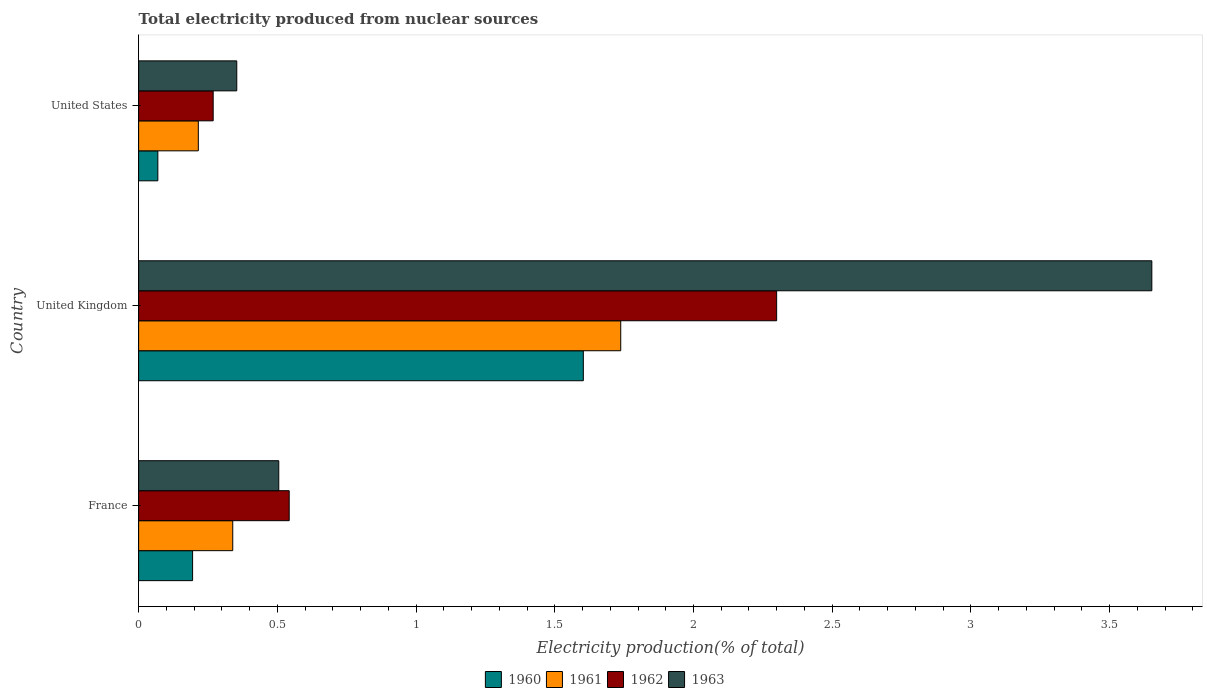How many different coloured bars are there?
Offer a very short reply. 4. Are the number of bars per tick equal to the number of legend labels?
Keep it short and to the point. Yes. How many bars are there on the 1st tick from the top?
Your answer should be compact. 4. In how many cases, is the number of bars for a given country not equal to the number of legend labels?
Offer a very short reply. 0. What is the total electricity produced in 1961 in United Kingdom?
Offer a terse response. 1.74. Across all countries, what is the maximum total electricity produced in 1960?
Offer a very short reply. 1.6. Across all countries, what is the minimum total electricity produced in 1961?
Provide a succinct answer. 0.22. In which country was the total electricity produced in 1961 minimum?
Offer a very short reply. United States. What is the total total electricity produced in 1960 in the graph?
Offer a very short reply. 1.87. What is the difference between the total electricity produced in 1963 in France and that in United Kingdom?
Provide a succinct answer. -3.15. What is the difference between the total electricity produced in 1961 in France and the total electricity produced in 1960 in United Kingdom?
Your answer should be compact. -1.26. What is the average total electricity produced in 1963 per country?
Your answer should be very brief. 1.5. What is the difference between the total electricity produced in 1961 and total electricity produced in 1963 in United States?
Your answer should be very brief. -0.14. In how many countries, is the total electricity produced in 1962 greater than 1.3 %?
Offer a very short reply. 1. What is the ratio of the total electricity produced in 1961 in France to that in United States?
Offer a very short reply. 1.58. Is the total electricity produced in 1960 in United Kingdom less than that in United States?
Your answer should be very brief. No. Is the difference between the total electricity produced in 1961 in United Kingdom and United States greater than the difference between the total electricity produced in 1963 in United Kingdom and United States?
Keep it short and to the point. No. What is the difference between the highest and the second highest total electricity produced in 1961?
Provide a succinct answer. 1.4. What is the difference between the highest and the lowest total electricity produced in 1961?
Provide a succinct answer. 1.52. In how many countries, is the total electricity produced in 1961 greater than the average total electricity produced in 1961 taken over all countries?
Offer a terse response. 1. Is it the case that in every country, the sum of the total electricity produced in 1963 and total electricity produced in 1960 is greater than the sum of total electricity produced in 1962 and total electricity produced in 1961?
Give a very brief answer. No. What does the 2nd bar from the top in United States represents?
Provide a succinct answer. 1962. What does the 4th bar from the bottom in United Kingdom represents?
Offer a very short reply. 1963. How many bars are there?
Ensure brevity in your answer.  12. What is the difference between two consecutive major ticks on the X-axis?
Keep it short and to the point. 0.5. Does the graph contain grids?
Your answer should be very brief. No. Where does the legend appear in the graph?
Your answer should be very brief. Bottom center. How are the legend labels stacked?
Ensure brevity in your answer.  Horizontal. What is the title of the graph?
Provide a short and direct response. Total electricity produced from nuclear sources. Does "2012" appear as one of the legend labels in the graph?
Ensure brevity in your answer.  No. What is the Electricity production(% of total) in 1960 in France?
Provide a succinct answer. 0.19. What is the Electricity production(% of total) of 1961 in France?
Your answer should be very brief. 0.34. What is the Electricity production(% of total) of 1962 in France?
Ensure brevity in your answer.  0.54. What is the Electricity production(% of total) of 1963 in France?
Your response must be concise. 0.51. What is the Electricity production(% of total) in 1960 in United Kingdom?
Provide a succinct answer. 1.6. What is the Electricity production(% of total) of 1961 in United Kingdom?
Offer a very short reply. 1.74. What is the Electricity production(% of total) in 1962 in United Kingdom?
Offer a very short reply. 2.3. What is the Electricity production(% of total) of 1963 in United Kingdom?
Offer a terse response. 3.65. What is the Electricity production(% of total) of 1960 in United States?
Your answer should be compact. 0.07. What is the Electricity production(% of total) in 1961 in United States?
Offer a terse response. 0.22. What is the Electricity production(% of total) in 1962 in United States?
Keep it short and to the point. 0.27. What is the Electricity production(% of total) in 1963 in United States?
Make the answer very short. 0.35. Across all countries, what is the maximum Electricity production(% of total) of 1960?
Your response must be concise. 1.6. Across all countries, what is the maximum Electricity production(% of total) in 1961?
Your answer should be very brief. 1.74. Across all countries, what is the maximum Electricity production(% of total) of 1962?
Keep it short and to the point. 2.3. Across all countries, what is the maximum Electricity production(% of total) in 1963?
Offer a very short reply. 3.65. Across all countries, what is the minimum Electricity production(% of total) in 1960?
Offer a very short reply. 0.07. Across all countries, what is the minimum Electricity production(% of total) in 1961?
Keep it short and to the point. 0.22. Across all countries, what is the minimum Electricity production(% of total) of 1962?
Give a very brief answer. 0.27. Across all countries, what is the minimum Electricity production(% of total) in 1963?
Give a very brief answer. 0.35. What is the total Electricity production(% of total) in 1960 in the graph?
Your answer should be very brief. 1.87. What is the total Electricity production(% of total) in 1961 in the graph?
Make the answer very short. 2.29. What is the total Electricity production(% of total) of 1962 in the graph?
Provide a succinct answer. 3.11. What is the total Electricity production(% of total) in 1963 in the graph?
Provide a short and direct response. 4.51. What is the difference between the Electricity production(% of total) of 1960 in France and that in United Kingdom?
Your answer should be very brief. -1.41. What is the difference between the Electricity production(% of total) of 1961 in France and that in United Kingdom?
Offer a terse response. -1.4. What is the difference between the Electricity production(% of total) of 1962 in France and that in United Kingdom?
Your answer should be compact. -1.76. What is the difference between the Electricity production(% of total) in 1963 in France and that in United Kingdom?
Your answer should be very brief. -3.15. What is the difference between the Electricity production(% of total) of 1960 in France and that in United States?
Ensure brevity in your answer.  0.13. What is the difference between the Electricity production(% of total) in 1961 in France and that in United States?
Provide a short and direct response. 0.12. What is the difference between the Electricity production(% of total) in 1962 in France and that in United States?
Your response must be concise. 0.27. What is the difference between the Electricity production(% of total) in 1963 in France and that in United States?
Make the answer very short. 0.15. What is the difference between the Electricity production(% of total) of 1960 in United Kingdom and that in United States?
Offer a very short reply. 1.53. What is the difference between the Electricity production(% of total) of 1961 in United Kingdom and that in United States?
Offer a terse response. 1.52. What is the difference between the Electricity production(% of total) in 1962 in United Kingdom and that in United States?
Your answer should be compact. 2.03. What is the difference between the Electricity production(% of total) in 1963 in United Kingdom and that in United States?
Offer a terse response. 3.3. What is the difference between the Electricity production(% of total) of 1960 in France and the Electricity production(% of total) of 1961 in United Kingdom?
Make the answer very short. -1.54. What is the difference between the Electricity production(% of total) of 1960 in France and the Electricity production(% of total) of 1962 in United Kingdom?
Offer a very short reply. -2.11. What is the difference between the Electricity production(% of total) in 1960 in France and the Electricity production(% of total) in 1963 in United Kingdom?
Keep it short and to the point. -3.46. What is the difference between the Electricity production(% of total) in 1961 in France and the Electricity production(% of total) in 1962 in United Kingdom?
Your answer should be compact. -1.96. What is the difference between the Electricity production(% of total) of 1961 in France and the Electricity production(% of total) of 1963 in United Kingdom?
Provide a short and direct response. -3.31. What is the difference between the Electricity production(% of total) in 1962 in France and the Electricity production(% of total) in 1963 in United Kingdom?
Keep it short and to the point. -3.11. What is the difference between the Electricity production(% of total) in 1960 in France and the Electricity production(% of total) in 1961 in United States?
Make the answer very short. -0.02. What is the difference between the Electricity production(% of total) in 1960 in France and the Electricity production(% of total) in 1962 in United States?
Give a very brief answer. -0.07. What is the difference between the Electricity production(% of total) of 1960 in France and the Electricity production(% of total) of 1963 in United States?
Keep it short and to the point. -0.16. What is the difference between the Electricity production(% of total) in 1961 in France and the Electricity production(% of total) in 1962 in United States?
Provide a succinct answer. 0.07. What is the difference between the Electricity production(% of total) in 1961 in France and the Electricity production(% of total) in 1963 in United States?
Give a very brief answer. -0.01. What is the difference between the Electricity production(% of total) in 1962 in France and the Electricity production(% of total) in 1963 in United States?
Offer a terse response. 0.19. What is the difference between the Electricity production(% of total) of 1960 in United Kingdom and the Electricity production(% of total) of 1961 in United States?
Make the answer very short. 1.39. What is the difference between the Electricity production(% of total) of 1960 in United Kingdom and the Electricity production(% of total) of 1962 in United States?
Provide a succinct answer. 1.33. What is the difference between the Electricity production(% of total) in 1960 in United Kingdom and the Electricity production(% of total) in 1963 in United States?
Give a very brief answer. 1.25. What is the difference between the Electricity production(% of total) in 1961 in United Kingdom and the Electricity production(% of total) in 1962 in United States?
Provide a short and direct response. 1.47. What is the difference between the Electricity production(% of total) in 1961 in United Kingdom and the Electricity production(% of total) in 1963 in United States?
Your response must be concise. 1.38. What is the difference between the Electricity production(% of total) of 1962 in United Kingdom and the Electricity production(% of total) of 1963 in United States?
Your answer should be very brief. 1.95. What is the average Electricity production(% of total) of 1960 per country?
Your answer should be very brief. 0.62. What is the average Electricity production(% of total) in 1961 per country?
Give a very brief answer. 0.76. What is the average Electricity production(% of total) in 1963 per country?
Offer a terse response. 1.5. What is the difference between the Electricity production(% of total) in 1960 and Electricity production(% of total) in 1961 in France?
Provide a succinct answer. -0.14. What is the difference between the Electricity production(% of total) of 1960 and Electricity production(% of total) of 1962 in France?
Provide a succinct answer. -0.35. What is the difference between the Electricity production(% of total) in 1960 and Electricity production(% of total) in 1963 in France?
Your response must be concise. -0.31. What is the difference between the Electricity production(% of total) of 1961 and Electricity production(% of total) of 1962 in France?
Provide a succinct answer. -0.2. What is the difference between the Electricity production(% of total) of 1961 and Electricity production(% of total) of 1963 in France?
Provide a succinct answer. -0.17. What is the difference between the Electricity production(% of total) in 1962 and Electricity production(% of total) in 1963 in France?
Provide a short and direct response. 0.04. What is the difference between the Electricity production(% of total) in 1960 and Electricity production(% of total) in 1961 in United Kingdom?
Provide a succinct answer. -0.13. What is the difference between the Electricity production(% of total) in 1960 and Electricity production(% of total) in 1962 in United Kingdom?
Provide a short and direct response. -0.7. What is the difference between the Electricity production(% of total) of 1960 and Electricity production(% of total) of 1963 in United Kingdom?
Offer a very short reply. -2.05. What is the difference between the Electricity production(% of total) of 1961 and Electricity production(% of total) of 1962 in United Kingdom?
Make the answer very short. -0.56. What is the difference between the Electricity production(% of total) in 1961 and Electricity production(% of total) in 1963 in United Kingdom?
Provide a short and direct response. -1.91. What is the difference between the Electricity production(% of total) in 1962 and Electricity production(% of total) in 1963 in United Kingdom?
Offer a terse response. -1.35. What is the difference between the Electricity production(% of total) of 1960 and Electricity production(% of total) of 1961 in United States?
Provide a short and direct response. -0.15. What is the difference between the Electricity production(% of total) of 1960 and Electricity production(% of total) of 1962 in United States?
Give a very brief answer. -0.2. What is the difference between the Electricity production(% of total) of 1960 and Electricity production(% of total) of 1963 in United States?
Your answer should be compact. -0.28. What is the difference between the Electricity production(% of total) in 1961 and Electricity production(% of total) in 1962 in United States?
Your answer should be compact. -0.05. What is the difference between the Electricity production(% of total) of 1961 and Electricity production(% of total) of 1963 in United States?
Offer a terse response. -0.14. What is the difference between the Electricity production(% of total) of 1962 and Electricity production(% of total) of 1963 in United States?
Give a very brief answer. -0.09. What is the ratio of the Electricity production(% of total) of 1960 in France to that in United Kingdom?
Offer a terse response. 0.12. What is the ratio of the Electricity production(% of total) of 1961 in France to that in United Kingdom?
Your answer should be compact. 0.2. What is the ratio of the Electricity production(% of total) of 1962 in France to that in United Kingdom?
Provide a succinct answer. 0.24. What is the ratio of the Electricity production(% of total) in 1963 in France to that in United Kingdom?
Give a very brief answer. 0.14. What is the ratio of the Electricity production(% of total) of 1960 in France to that in United States?
Provide a succinct answer. 2.81. What is the ratio of the Electricity production(% of total) in 1961 in France to that in United States?
Ensure brevity in your answer.  1.58. What is the ratio of the Electricity production(% of total) of 1962 in France to that in United States?
Your answer should be compact. 2.02. What is the ratio of the Electricity production(% of total) in 1963 in France to that in United States?
Make the answer very short. 1.43. What is the ratio of the Electricity production(% of total) in 1960 in United Kingdom to that in United States?
Give a very brief answer. 23.14. What is the ratio of the Electricity production(% of total) in 1961 in United Kingdom to that in United States?
Keep it short and to the point. 8.08. What is the ratio of the Electricity production(% of total) of 1962 in United Kingdom to that in United States?
Give a very brief answer. 8.56. What is the ratio of the Electricity production(% of total) of 1963 in United Kingdom to that in United States?
Offer a very short reply. 10.32. What is the difference between the highest and the second highest Electricity production(% of total) in 1960?
Offer a terse response. 1.41. What is the difference between the highest and the second highest Electricity production(% of total) of 1961?
Offer a very short reply. 1.4. What is the difference between the highest and the second highest Electricity production(% of total) of 1962?
Give a very brief answer. 1.76. What is the difference between the highest and the second highest Electricity production(% of total) of 1963?
Make the answer very short. 3.15. What is the difference between the highest and the lowest Electricity production(% of total) in 1960?
Provide a succinct answer. 1.53. What is the difference between the highest and the lowest Electricity production(% of total) of 1961?
Offer a terse response. 1.52. What is the difference between the highest and the lowest Electricity production(% of total) of 1962?
Ensure brevity in your answer.  2.03. What is the difference between the highest and the lowest Electricity production(% of total) of 1963?
Ensure brevity in your answer.  3.3. 